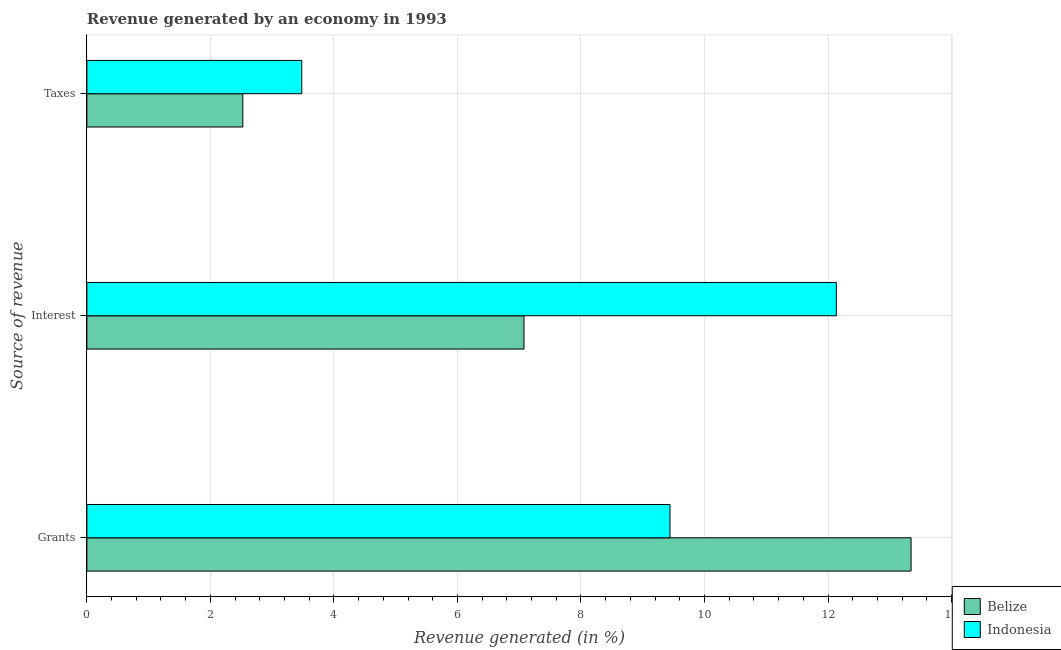How many different coloured bars are there?
Your answer should be very brief. 2. Are the number of bars per tick equal to the number of legend labels?
Ensure brevity in your answer.  Yes. How many bars are there on the 2nd tick from the bottom?
Provide a succinct answer. 2. What is the label of the 1st group of bars from the top?
Ensure brevity in your answer.  Taxes. What is the percentage of revenue generated by grants in Indonesia?
Your answer should be compact. 9.44. Across all countries, what is the maximum percentage of revenue generated by grants?
Keep it short and to the point. 13.34. Across all countries, what is the minimum percentage of revenue generated by grants?
Your response must be concise. 9.44. What is the total percentage of revenue generated by grants in the graph?
Offer a terse response. 22.79. What is the difference between the percentage of revenue generated by grants in Indonesia and that in Belize?
Provide a short and direct response. -3.9. What is the difference between the percentage of revenue generated by grants in Belize and the percentage of revenue generated by interest in Indonesia?
Give a very brief answer. 1.21. What is the average percentage of revenue generated by taxes per country?
Provide a short and direct response. 3. What is the difference between the percentage of revenue generated by grants and percentage of revenue generated by interest in Indonesia?
Provide a succinct answer. -2.69. What is the ratio of the percentage of revenue generated by interest in Belize to that in Indonesia?
Keep it short and to the point. 0.58. What is the difference between the highest and the second highest percentage of revenue generated by interest?
Your answer should be compact. 5.06. What is the difference between the highest and the lowest percentage of revenue generated by taxes?
Your response must be concise. 0.95. Is the sum of the percentage of revenue generated by interest in Belize and Indonesia greater than the maximum percentage of revenue generated by grants across all countries?
Your answer should be very brief. Yes. What does the 2nd bar from the top in Taxes represents?
Ensure brevity in your answer.  Belize. What does the 1st bar from the bottom in Grants represents?
Offer a terse response. Belize. Are all the bars in the graph horizontal?
Keep it short and to the point. Yes. What is the difference between two consecutive major ticks on the X-axis?
Offer a terse response. 2. Are the values on the major ticks of X-axis written in scientific E-notation?
Provide a short and direct response. No. How many legend labels are there?
Give a very brief answer. 2. How are the legend labels stacked?
Give a very brief answer. Vertical. What is the title of the graph?
Make the answer very short. Revenue generated by an economy in 1993. What is the label or title of the X-axis?
Make the answer very short. Revenue generated (in %). What is the label or title of the Y-axis?
Your answer should be compact. Source of revenue. What is the Revenue generated (in %) of Belize in Grants?
Your answer should be compact. 13.34. What is the Revenue generated (in %) in Indonesia in Grants?
Offer a very short reply. 9.44. What is the Revenue generated (in %) of Belize in Interest?
Your answer should be very brief. 7.08. What is the Revenue generated (in %) of Indonesia in Interest?
Ensure brevity in your answer.  12.13. What is the Revenue generated (in %) in Belize in Taxes?
Offer a terse response. 2.52. What is the Revenue generated (in %) in Indonesia in Taxes?
Your answer should be very brief. 3.48. Across all Source of revenue, what is the maximum Revenue generated (in %) in Belize?
Your answer should be very brief. 13.34. Across all Source of revenue, what is the maximum Revenue generated (in %) of Indonesia?
Offer a very short reply. 12.13. Across all Source of revenue, what is the minimum Revenue generated (in %) in Belize?
Your answer should be very brief. 2.52. Across all Source of revenue, what is the minimum Revenue generated (in %) of Indonesia?
Offer a terse response. 3.48. What is the total Revenue generated (in %) of Belize in the graph?
Make the answer very short. 22.95. What is the total Revenue generated (in %) of Indonesia in the graph?
Offer a terse response. 25.06. What is the difference between the Revenue generated (in %) of Belize in Grants and that in Interest?
Your answer should be very brief. 6.27. What is the difference between the Revenue generated (in %) in Indonesia in Grants and that in Interest?
Offer a very short reply. -2.69. What is the difference between the Revenue generated (in %) in Belize in Grants and that in Taxes?
Your answer should be very brief. 10.82. What is the difference between the Revenue generated (in %) in Indonesia in Grants and that in Taxes?
Offer a terse response. 5.96. What is the difference between the Revenue generated (in %) in Belize in Interest and that in Taxes?
Your answer should be very brief. 4.55. What is the difference between the Revenue generated (in %) in Indonesia in Interest and that in Taxes?
Keep it short and to the point. 8.66. What is the difference between the Revenue generated (in %) in Belize in Grants and the Revenue generated (in %) in Indonesia in Interest?
Your answer should be compact. 1.21. What is the difference between the Revenue generated (in %) of Belize in Grants and the Revenue generated (in %) of Indonesia in Taxes?
Provide a succinct answer. 9.87. What is the difference between the Revenue generated (in %) of Belize in Interest and the Revenue generated (in %) of Indonesia in Taxes?
Provide a succinct answer. 3.6. What is the average Revenue generated (in %) in Belize per Source of revenue?
Ensure brevity in your answer.  7.65. What is the average Revenue generated (in %) in Indonesia per Source of revenue?
Ensure brevity in your answer.  8.35. What is the difference between the Revenue generated (in %) in Belize and Revenue generated (in %) in Indonesia in Grants?
Keep it short and to the point. 3.9. What is the difference between the Revenue generated (in %) of Belize and Revenue generated (in %) of Indonesia in Interest?
Your response must be concise. -5.06. What is the difference between the Revenue generated (in %) of Belize and Revenue generated (in %) of Indonesia in Taxes?
Your answer should be compact. -0.95. What is the ratio of the Revenue generated (in %) in Belize in Grants to that in Interest?
Keep it short and to the point. 1.89. What is the ratio of the Revenue generated (in %) in Indonesia in Grants to that in Interest?
Your response must be concise. 0.78. What is the ratio of the Revenue generated (in %) of Belize in Grants to that in Taxes?
Your response must be concise. 5.29. What is the ratio of the Revenue generated (in %) of Indonesia in Grants to that in Taxes?
Offer a terse response. 2.71. What is the ratio of the Revenue generated (in %) in Belize in Interest to that in Taxes?
Provide a short and direct response. 2.8. What is the ratio of the Revenue generated (in %) of Indonesia in Interest to that in Taxes?
Ensure brevity in your answer.  3.49. What is the difference between the highest and the second highest Revenue generated (in %) in Belize?
Offer a very short reply. 6.27. What is the difference between the highest and the second highest Revenue generated (in %) in Indonesia?
Your response must be concise. 2.69. What is the difference between the highest and the lowest Revenue generated (in %) in Belize?
Make the answer very short. 10.82. What is the difference between the highest and the lowest Revenue generated (in %) of Indonesia?
Provide a succinct answer. 8.66. 